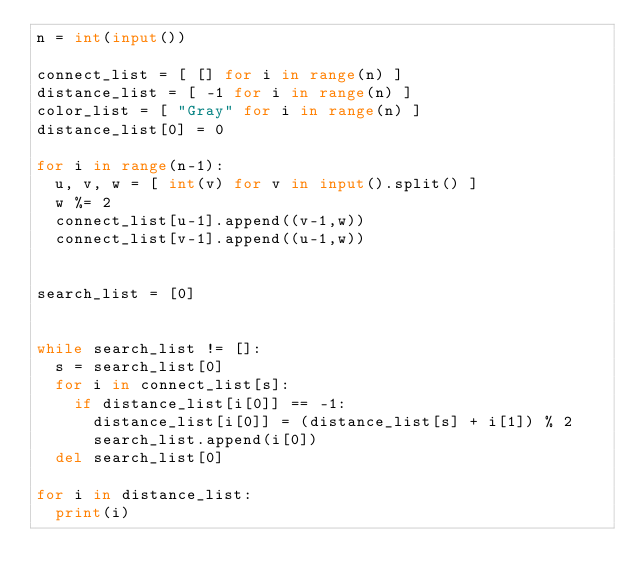Convert code to text. <code><loc_0><loc_0><loc_500><loc_500><_Python_>n = int(input())

connect_list = [ [] for i in range(n) ]
distance_list = [ -1 for i in range(n) ]
color_list = [ "Gray" for i in range(n) ]
distance_list[0] = 0

for i in range(n-1):
	u, v, w = [ int(v) for v in input().split() ]
	w %= 2
	connect_list[u-1].append((v-1,w))
	connect_list[v-1].append((u-1,w))
	

search_list = [0]


while search_list != []:
	s = search_list[0]
	for i in connect_list[s]:
		if distance_list[i[0]] == -1:
			distance_list[i[0]] = (distance_list[s] + i[1]) % 2
			search_list.append(i[0])
	del search_list[0]

for i in distance_list:
	print(i)</code> 